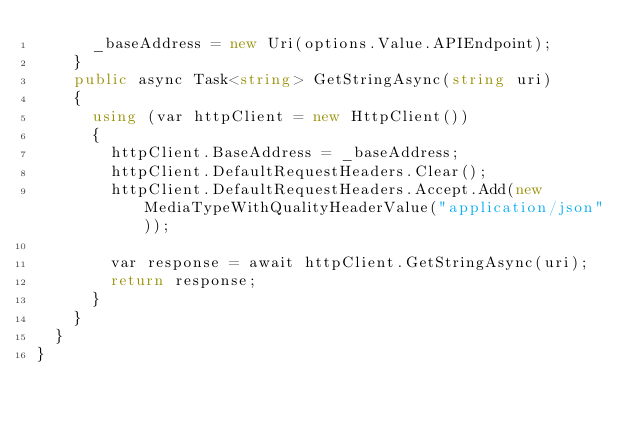Convert code to text. <code><loc_0><loc_0><loc_500><loc_500><_C#_>      _baseAddress = new Uri(options.Value.APIEndpoint);
    }
    public async Task<string> GetStringAsync(string uri)
    {
      using (var httpClient = new HttpClient())
      {
        httpClient.BaseAddress = _baseAddress;
        httpClient.DefaultRequestHeaders.Clear();
        httpClient.DefaultRequestHeaders.Accept.Add(new MediaTypeWithQualityHeaderValue("application/json"));

        var response = await httpClient.GetStringAsync(uri);
        return response;
      }
    }
  }
}
</code> 